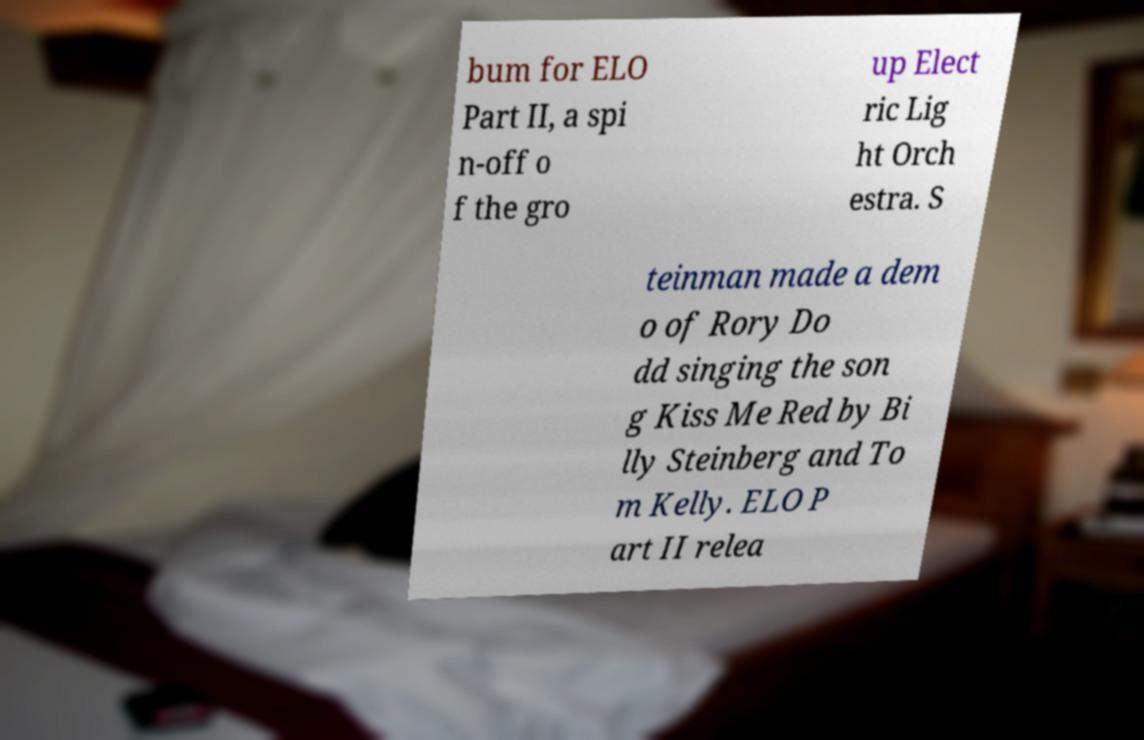Please identify and transcribe the text found in this image. bum for ELO Part II, a spi n-off o f the gro up Elect ric Lig ht Orch estra. S teinman made a dem o of Rory Do dd singing the son g Kiss Me Red by Bi lly Steinberg and To m Kelly. ELO P art II relea 